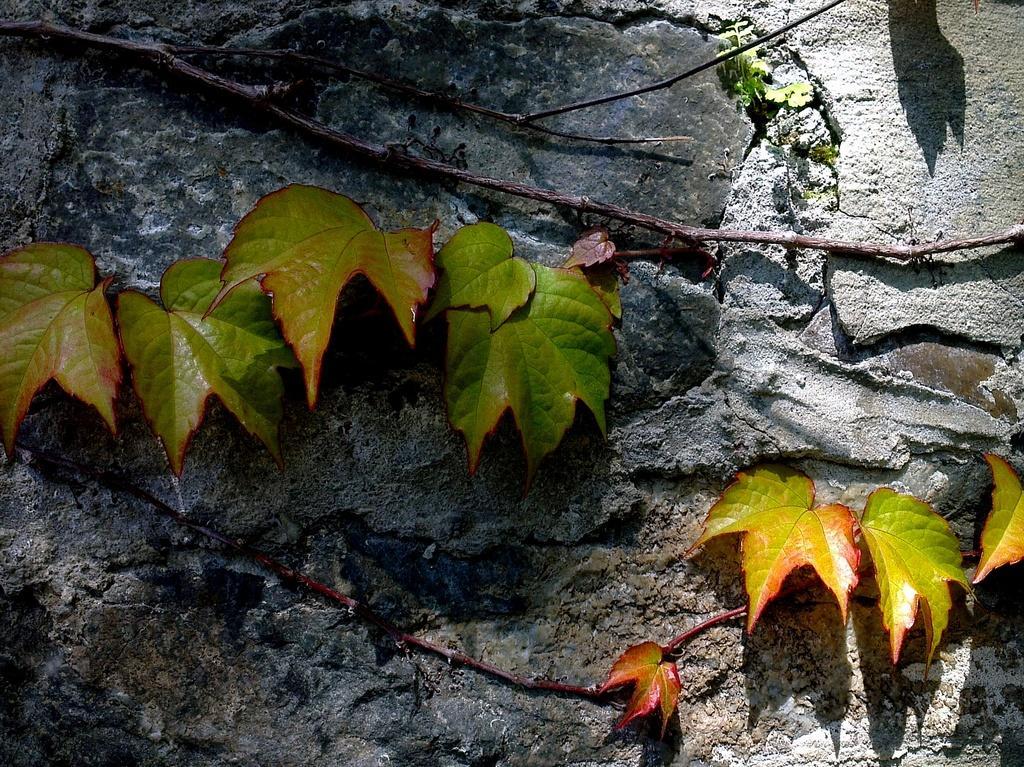How would you summarize this image in a sentence or two? In the picture I can see leaves and stems on a rock surface. 